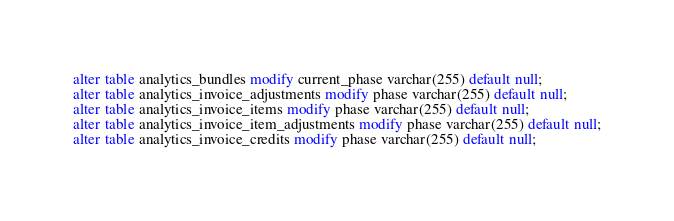<code> <loc_0><loc_0><loc_500><loc_500><_SQL_>alter table analytics_bundles modify current_phase varchar(255) default null;
alter table analytics_invoice_adjustments modify phase varchar(255) default null;
alter table analytics_invoice_items modify phase varchar(255) default null;
alter table analytics_invoice_item_adjustments modify phase varchar(255) default null;
alter table analytics_invoice_credits modify phase varchar(255) default null;</code> 